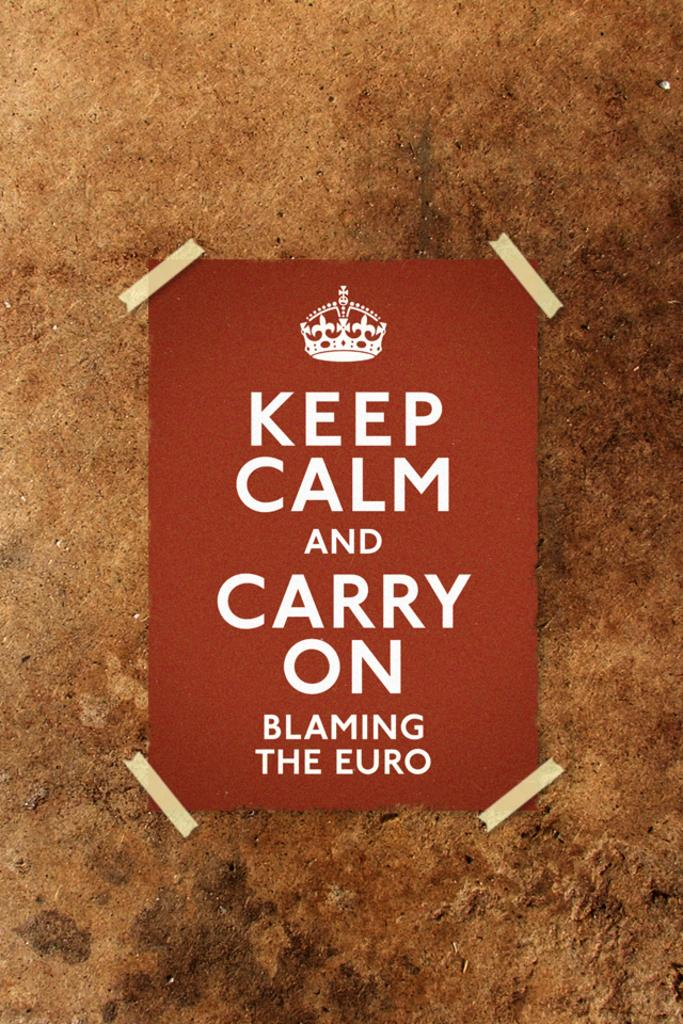<image>
Write a terse but informative summary of the picture. A sign with a small crown says Keep Calm and Carry on. 